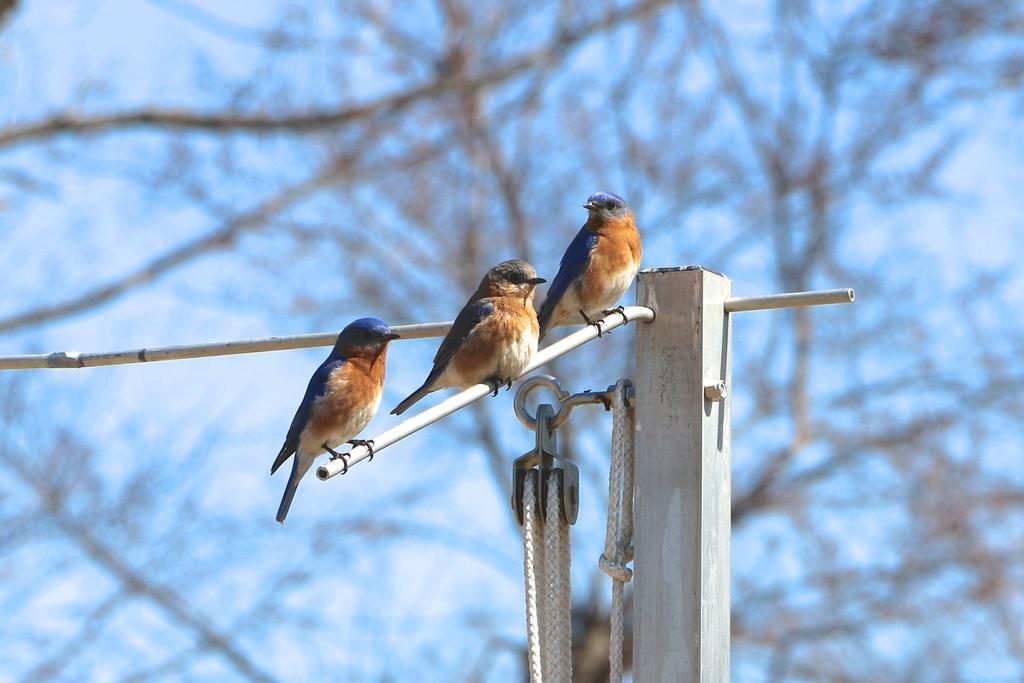In one or two sentences, can you explain what this image depicts? In the picture there is a wooden pole and three birds were sitting on the stick that is attached to that pole, the background of the pole is blur. 